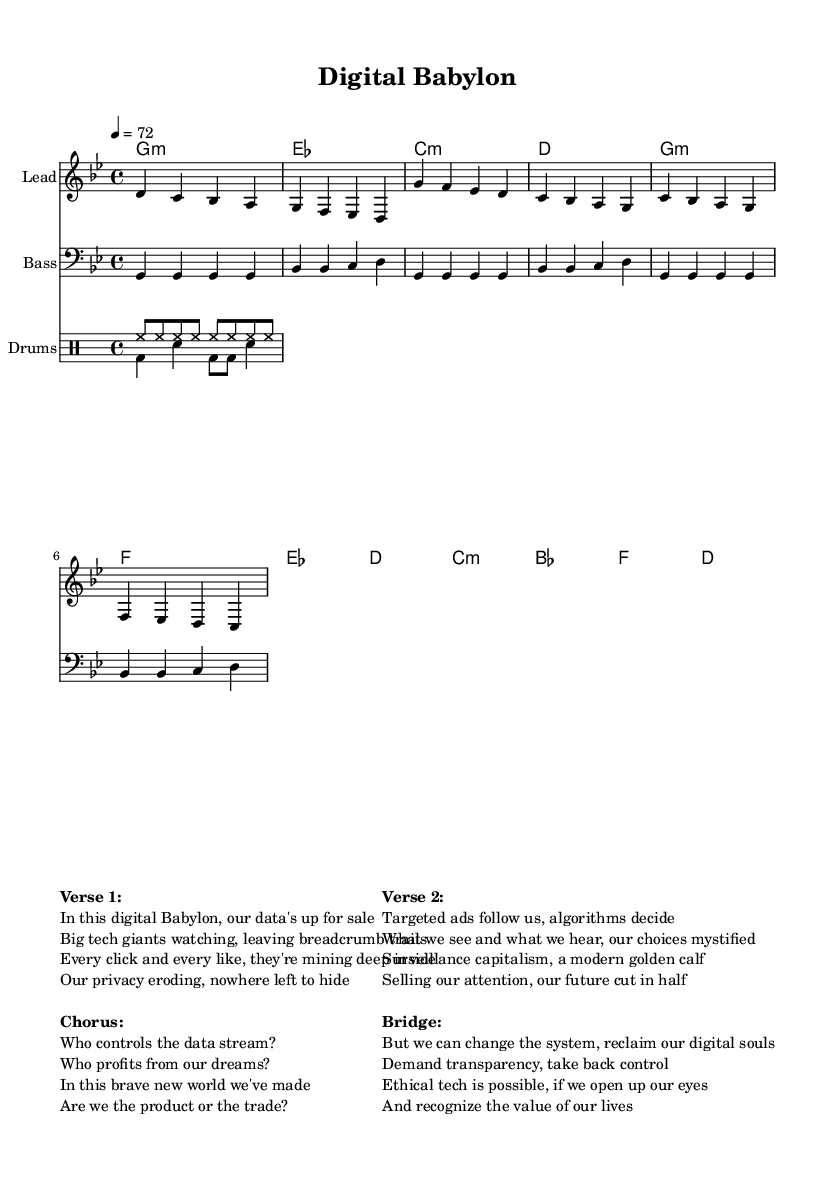What is the key signature of this music? The key signature is G minor, which has two flats (B flat and E flat). This can be determined by identifying the key signature symbol present at the beginning of the staff.
Answer: G minor What is the time signature of this music? The time signature is 4/4, indicated at the beginning of the score. This means there are four beats per measure, and a quarter note receives one beat.
Answer: 4/4 What is the tempo marking of this piece? The tempo marking is 72, which is indicated in the score as "4 = 72." This means there are 72 beats per minute, establishing the speed of the music.
Answer: 72 How many measures are in the chorus section? The chorus section consists of four measures, which can be counted in the score based on the grouping of the notes used during the chorus part specified in the music.
Answer: 4 What is the common rhythmic pattern used in the drums? The drums feature a consistent pattern where the hi-hat plays eighth notes, while the bass drum and snare contribute to syncopated accents, providing the underlying groove typical of reggae music.
Answer: Eighth notes What is the primary thematic concern of the lyrics? The primary thematic concern revolves around the ethical implications of surveillance capitalism and data privacy, which is explicitly highlighted in the lyrics referring to data being sold and manipulated by tech giants.
Answer: Data privacy What type of groove is established by the bassline? The bassline establishes a repetitive and syncopated reggae groove, characterized by offbeat accents that create a laid-back feel, typical of reggae music.
Answer: Reggae groove 